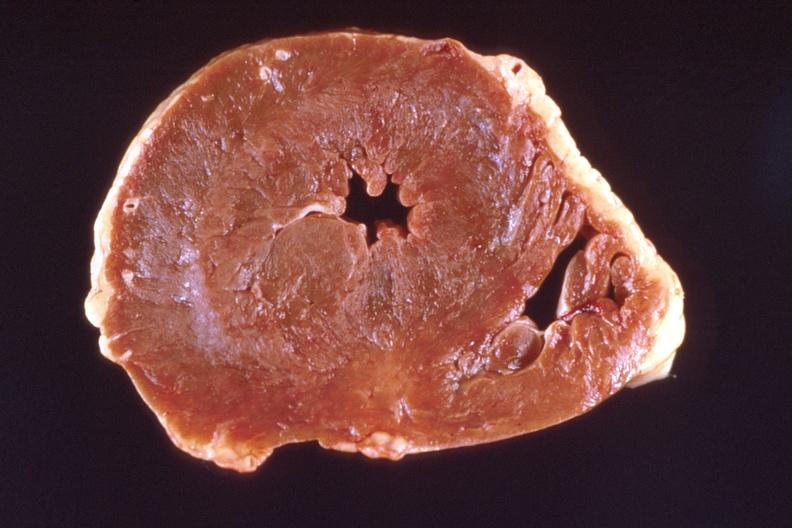does natural color show heart?
Answer the question using a single word or phrase. No 